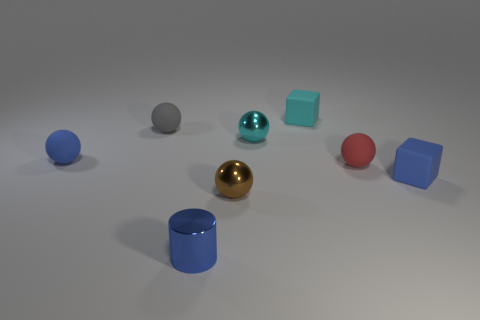Subtract all small cyan balls. How many balls are left? 4 Subtract all cyan balls. How many balls are left? 4 Subtract all green balls. Subtract all blue cylinders. How many balls are left? 5 Add 1 red matte objects. How many objects exist? 9 Subtract all spheres. How many objects are left? 3 Add 1 tiny cyan shiny spheres. How many tiny cyan shiny spheres exist? 2 Subtract 1 blue cylinders. How many objects are left? 7 Subtract all small brown balls. Subtract all metallic cylinders. How many objects are left? 6 Add 4 red matte spheres. How many red matte spheres are left? 5 